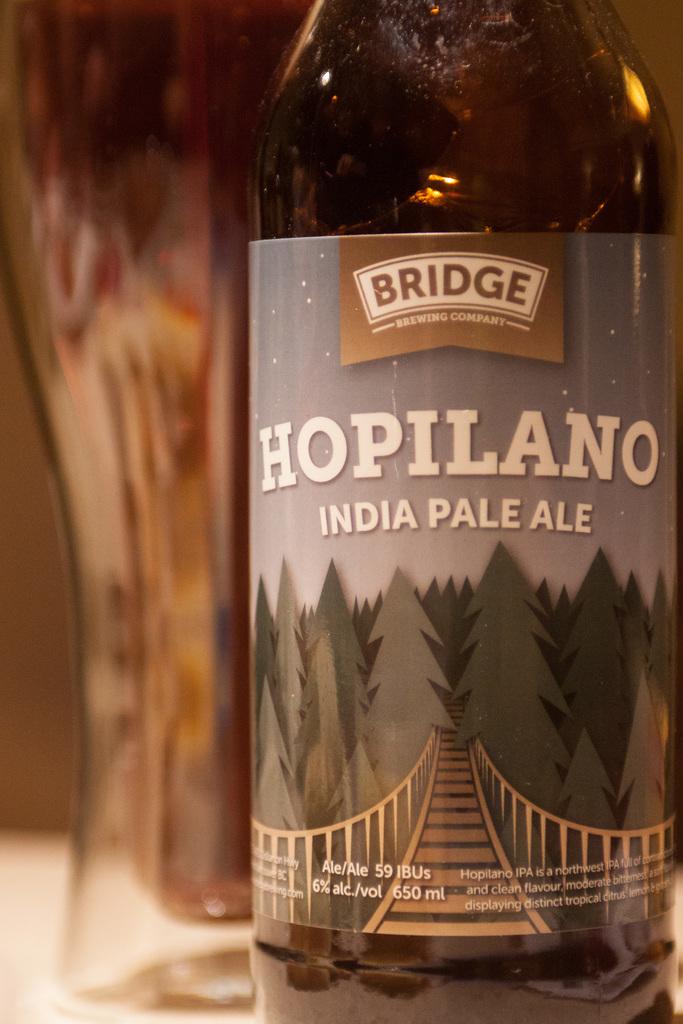What is the alcohol volume of this beer?
Provide a short and direct response. 6%. 